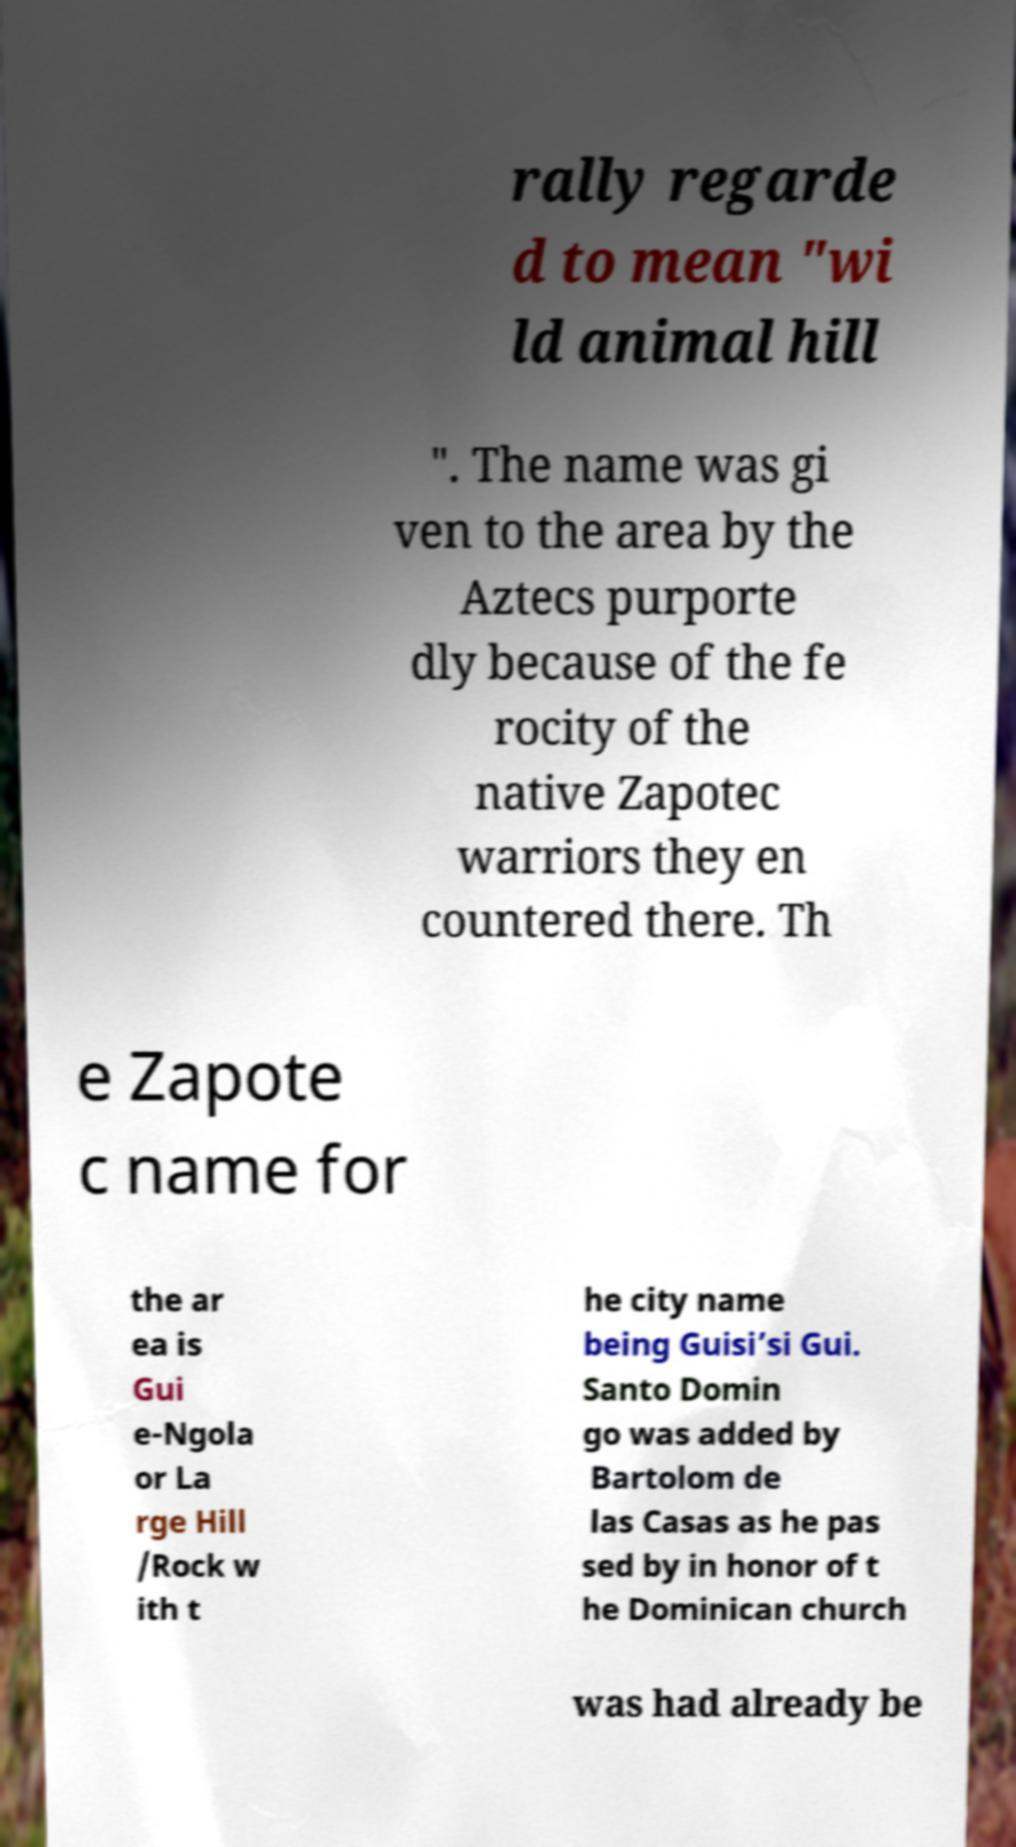There's text embedded in this image that I need extracted. Can you transcribe it verbatim? rally regarde d to mean "wi ld animal hill ". The name was gi ven to the area by the Aztecs purporte dly because of the fe rocity of the native Zapotec warriors they en countered there. Th e Zapote c name for the ar ea is Gui e-Ngola or La rge Hill /Rock w ith t he city name being Guisi’si Gui. Santo Domin go was added by Bartolom de las Casas as he pas sed by in honor of t he Dominican church was had already be 